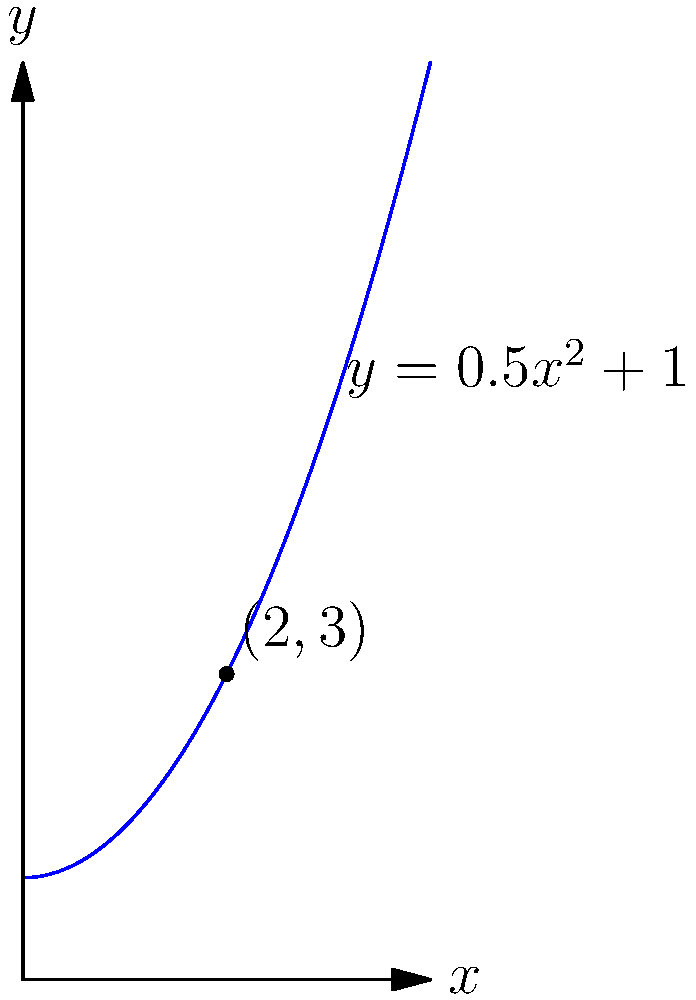As a retired horse racing commentator, you're analyzing the movement of a champion horse along a curved racetrack. The horse's position is given by the function $y = 0.5x^2 + 1$, where $x$ and $y$ are measured in furlongs. Calculate the horse's velocity when it reaches the point $(2,3)$ on the track. To find the velocity at a specific point, we need to calculate the derivative of the position function and evaluate it at the given point. Let's break this down step-by-step:

1) The position function is $y = 0.5x^2 + 1$

2) To find the velocity function, we need to take the derivative of the position function:
   $\frac{dy}{dx} = \frac{d}{dx}(0.5x^2 + 1) = x$

3) The velocity function is therefore $v(x) = x$

4) We're asked to find the velocity at the point $(2,3)$. Since the velocity function depends only on $x$, we only need the $x$-coordinate, which is 2.

5) Plugging $x=2$ into our velocity function:
   $v(2) = 2$

6) Therefore, the horse's velocity at the point $(2,3)$ is 2 furlongs per unit time.

Note: In horse racing, velocity is typically measured in furlongs per second or miles per hour. Without a specified time unit, we'll leave the answer as 2 furlongs per unit time.
Answer: 2 furlongs per unit time 